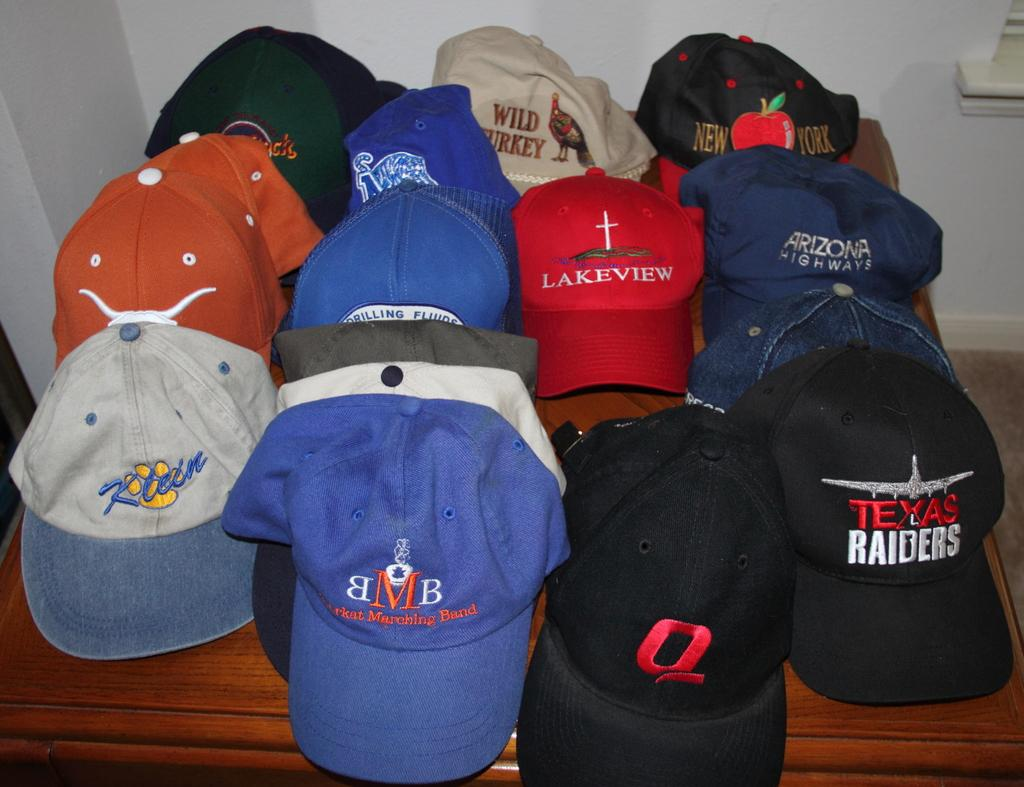<image>
Create a compact narrative representing the image presented. A table filled with hats, one of which says Texas Raiders. 